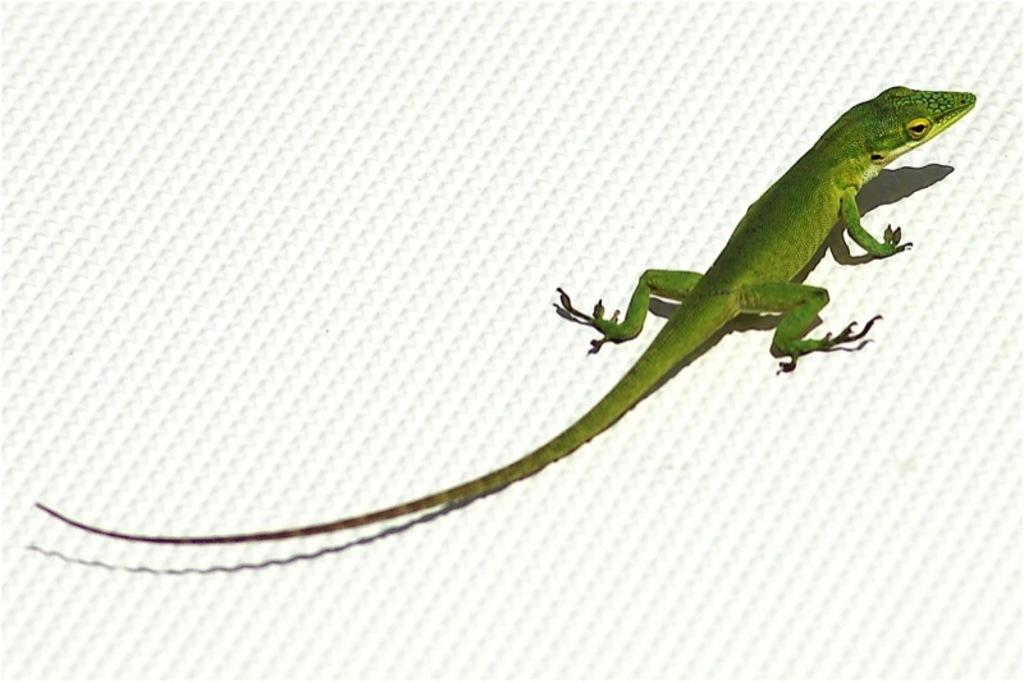What type of image is being described? The image is an edited picture. What can be seen in the image? There is a reptile in the image. Where is the reptile located in the image? The reptile is on an object. What type of quartz can be seen in the image? There is no quartz present in the image. How much lead is visible in the image? There is no lead present in the image. 